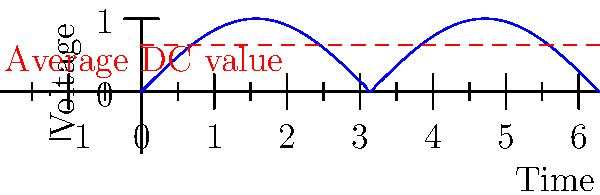In the output waveform of a full-wave bridge rectifier shown above, what is the average DC value in terms of the peak voltage $V_p$ of the input sine wave? To find the average DC value of a full-wave rectified sine wave:

1. The instantaneous voltage of a rectified sine wave is given by:
   $v(t) = V_p |\sin(\omega t)|$

2. The average value is calculated by integrating over half a cycle (as the waveform repeats every $\pi$ radians) and dividing by $\pi$:
   $V_{avg} = \frac{1}{\pi} \int_0^\pi V_p \sin(\theta) d\theta$

3. Solving this integral:
   $V_{avg} = \frac{V_p}{\pi} [-\cos(\theta)]_0^\pi = \frac{V_p}{\pi} [(-\cos(\pi)) - (-\cos(0))]$

4. Simplify:
   $V_{avg} = \frac{V_p}{\pi} [1 - (-1)] = \frac{2V_p}{\pi}$

5. Therefore, the average DC value of a full-wave rectified sine wave is $\frac{2}{\pi}$ times the peak voltage of the input sine wave.

This value is represented by the dashed red line in the graph.
Answer: $\frac{2V_p}{\pi}$ 